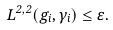Convert formula to latex. <formula><loc_0><loc_0><loc_500><loc_500>L ^ { 2 , 2 } ( g _ { i } , \gamma _ { i } ) \leq \varepsilon .</formula> 